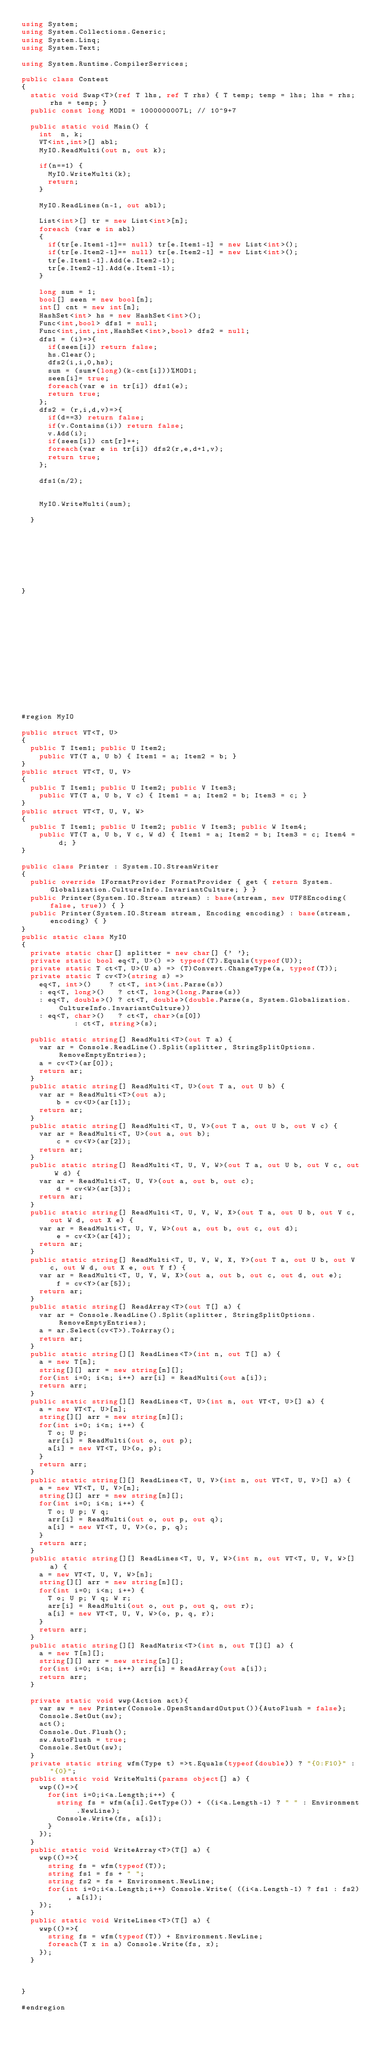<code> <loc_0><loc_0><loc_500><loc_500><_C#_>using System;
using System.Collections.Generic;
using System.Linq;
using System.Text;

using System.Runtime.CompilerServices;

public class Contest
{
	static void Swap<T>(ref T lhs, ref T rhs) { T temp; temp = lhs; lhs = rhs; rhs = temp; }
	public const long MOD1 = 1000000007L; // 10^9+7

	public static void Main() {
		int  n, k;
		VT<int,int>[] abl;
		MyIO.ReadMulti(out n, out k);

		if(n==1) {
			MyIO.WriteMulti(k);
			return;
		}

		MyIO.ReadLines(n-1, out abl);

		List<int>[] tr = new List<int>[n];
		foreach (var e in abl)
		{
			if(tr[e.Item1-1]== null) tr[e.Item1-1] = new List<int>();
			if(tr[e.Item2-1]== null) tr[e.Item2-1] = new List<int>();
			tr[e.Item1-1].Add(e.Item2-1);
			tr[e.Item2-1].Add(e.Item1-1);
		}

		long sum = 1;
		bool[] seen = new bool[n];
		int[] cnt = new int[n];
		HashSet<int> hs = new HashSet<int>();
		Func<int,bool> dfs1 = null;
		Func<int,int,int,HashSet<int>,bool> dfs2 = null;
		dfs1 = (i)=>{
			if(seen[i]) return false;
			hs.Clear();
			dfs2(i,i,0,hs);
			sum = (sum*(long)(k-cnt[i]))%MOD1;
			seen[i]= true;
			foreach(var e in tr[i]) dfs1(e);
			return true;
		};
		dfs2 = (r,i,d,v)=>{
			if(d==3) return false;
			if(v.Contains(i)) return false;
			v.Add(i);
			if(seen[i]) cnt[r]++;
			foreach(var e in tr[i]) dfs2(r,e,d+1,v);
			return true;
		};

		dfs1(n/2);


		MyIO.WriteMulti(sum);

	}








}















#region MyIO

public struct VT<T, U>
{
	public T Item1; public U Item2;
    public VT(T a, U b) { Item1 = a; Item2 = b; }
}
public struct VT<T, U, V>
{
	public T Item1; public U Item2; public V Item3;
    public VT(T a, U b, V c) { Item1 = a; Item2 = b; Item3 = c; }
}
public struct VT<T, U, V, W>
{
	public T Item1; public U Item2; public V Item3; public W Item4;
    public VT(T a, U b, V c, W d) { Item1 = a; Item2 = b; Item3 = c; Item4 = d; }
}

public class Printer : System.IO.StreamWriter
{
	public override IFormatProvider FormatProvider { get { return System.Globalization.CultureInfo.InvariantCulture; } }
	public Printer(System.IO.Stream stream) : base(stream, new UTF8Encoding(false, true)) { }
	public Printer(System.IO.Stream stream, Encoding encoding) : base(stream, encoding) { }
}
public static class MyIO
{
	private static char[] splitter = new char[] {' '};
	private static bool eq<T, U>() => typeof(T).Equals(typeof(U));
	private static T ct<T, U>(U a) => (T)Convert.ChangeType(a, typeof(T));
	private static T cv<T>(string s) =>
		eq<T, int>()    ? ct<T, int>(int.Parse(s))
	  : eq<T, long>()   ? ct<T, long>(long.Parse(s))
	  : eq<T, double>() ? ct<T, double>(double.Parse(s, System.Globalization.CultureInfo.InvariantCulture))
	  : eq<T, char>()   ? ct<T, char>(s[0])
						: ct<T, string>(s);
			
	public static string[] ReadMulti<T>(out T a) {
		var ar = Console.ReadLine().Split(splitter, StringSplitOptions.RemoveEmptyEntries); 
		a = cv<T>(ar[0]);
		return ar;
	}
	public static string[] ReadMulti<T, U>(out T a, out U b) {
		var ar = ReadMulti<T>(out a); 
        b = cv<U>(ar[1]);
		return ar;
	}
	public static string[] ReadMulti<T, U, V>(out T a, out U b, out V c) {
		var ar = ReadMulti<T, U>(out a, out b); 
        c = cv<V>(ar[2]);
		return ar;
	}
	public static string[] ReadMulti<T, U, V, W>(out T a, out U b, out V c, out W d) {
		var ar = ReadMulti<T, U, V>(out a, out b, out c); 
        d = cv<W>(ar[3]);
		return ar;
	}
	public static string[] ReadMulti<T, U, V, W, X>(out T a, out U b, out V c, out W d, out X e) {
		var ar = ReadMulti<T, U, V, W>(out a, out b, out c, out d); 
        e = cv<X>(ar[4]);
		return ar;
	}
	public static string[] ReadMulti<T, U, V, W, X, Y>(out T a, out U b, out V c, out W d, out X e, out Y f) {
		var ar = ReadMulti<T, U, V, W, X>(out a, out b, out c, out d, out e); 
        f = cv<Y>(ar[5]);
		return ar;
	}
	public static string[] ReadArray<T>(out T[] a) {		
		var ar = Console.ReadLine().Split(splitter, StringSplitOptions.RemoveEmptyEntries);
		a = ar.Select(cv<T>).ToArray();
		return ar;
	}		
	public static string[][] ReadLines<T>(int n, out T[] a) {
		a = new T[n];
		string[][] arr = new string[n][];
		for(int i=0; i<n; i++) arr[i] = ReadMulti(out a[i]);
		return arr;
	}
	public static string[][] ReadLines<T, U>(int n, out VT<T, U>[] a) {
		a = new VT<T, U>[n];
		string[][] arr = new string[n][];
		for(int i=0; i<n; i++) {
			T o; U p;
			arr[i] = ReadMulti(out o, out p);
			a[i] = new VT<T, U>(o, p);
		}
		return arr;
	}
	public static string[][] ReadLines<T, U, V>(int n, out VT<T, U, V>[] a) {
		a = new VT<T, U, V>[n];
		string[][] arr = new string[n][];
		for(int i=0; i<n; i++) {
			T o; U p; V q;
			arr[i] = ReadMulti(out o, out p, out q);
			a[i] = new VT<T, U, V>(o, p, q);
		}
		return arr;
	}
	public static string[][] ReadLines<T, U, V, W>(int n, out VT<T, U, V, W>[] a) {
		a = new VT<T, U, V, W>[n];
		string[][] arr = new string[n][];
		for(int i=0; i<n; i++) {
			T o; U p; V q; W r;
			arr[i] = ReadMulti(out o, out p, out q, out r);
			a[i] = new VT<T, U, V, W>(o, p, q, r);
		}
		return arr;
	}
	public static string[][] ReadMatrix<T>(int n, out T[][] a) {
		a = new T[n][];
		string[][] arr = new string[n][];
		for(int i=0; i<n; i++) arr[i] = ReadArray(out a[i]);
		return arr;
	}

	private static void wwp(Action act){
		var sw = new Printer(Console.OpenStandardOutput()){AutoFlush = false};
		Console.SetOut(sw);
		act();
		Console.Out.Flush();
		sw.AutoFlush = true;
		Console.SetOut(sw);
	}
	private static string wfm(Type t) =>t.Equals(typeof(double)) ? "{0:F10}" : "{0}";
	public static void WriteMulti(params object[] a) {
		wwp(()=>{
			for(int i=0;i<a.Length;i++) {
				string fs = wfm(a[i].GetType()) + ((i<a.Length-1) ? " " : Environment.NewLine);
				Console.Write(fs, a[i]);
			}
		});
	}
	public static void WriteArray<T>(T[] a) {
		wwp(()=>{
			string fs = wfm(typeof(T));
			string fs1 = fs + " ";
			string fs2 = fs + Environment.NewLine;
			for(int i=0;i<a.Length;i++) Console.Write( ((i<a.Length-1) ? fs1 : fs2), a[i]);
		});
	}
	public static void WriteLines<T>(T[] a) {
		wwp(()=>{
			string fs = wfm(typeof(T)) + Environment.NewLine;
			foreach(T x in a) Console.Write(fs, x);
		});
	}



}

#endregion

</code> 